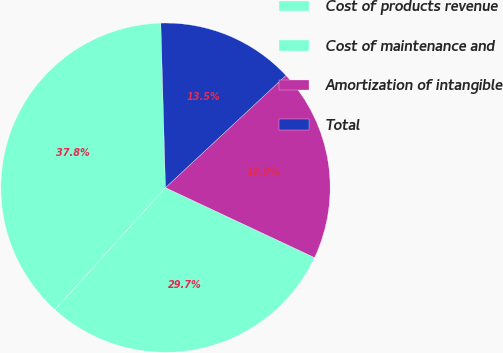<chart> <loc_0><loc_0><loc_500><loc_500><pie_chart><fcel>Cost of products revenue<fcel>Cost of maintenance and<fcel>Amortization of intangible<fcel>Total<nl><fcel>37.84%<fcel>29.73%<fcel>18.92%<fcel>13.51%<nl></chart> 